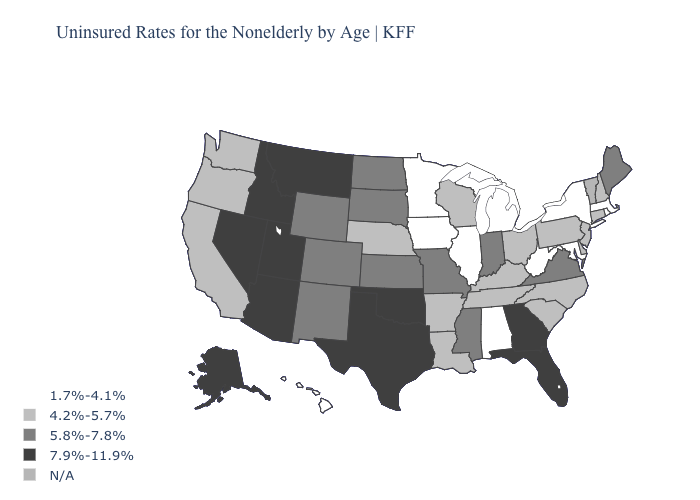What is the value of Arkansas?
Give a very brief answer. 4.2%-5.7%. Is the legend a continuous bar?
Short answer required. No. What is the highest value in states that border Iowa?
Be succinct. 5.8%-7.8%. Does the map have missing data?
Answer briefly. Yes. Name the states that have a value in the range 1.7%-4.1%?
Keep it brief. Alabama, Hawaii, Illinois, Iowa, Maryland, Massachusetts, Michigan, Minnesota, New York, Rhode Island, West Virginia. What is the value of North Dakota?
Short answer required. 5.8%-7.8%. What is the lowest value in the West?
Be succinct. 1.7%-4.1%. What is the highest value in states that border Utah?
Write a very short answer. 7.9%-11.9%. Among the states that border North Carolina , does Tennessee have the lowest value?
Quick response, please. Yes. Which states hav the highest value in the South?
Be succinct. Florida, Georgia, Oklahoma, Texas. What is the highest value in the USA?
Give a very brief answer. 7.9%-11.9%. Among the states that border North Dakota , which have the highest value?
Quick response, please. Montana. Does Kansas have the highest value in the MidWest?
Be succinct. Yes. Name the states that have a value in the range N/A?
Short answer required. Vermont. Name the states that have a value in the range 5.8%-7.8%?
Answer briefly. Colorado, Indiana, Kansas, Maine, Mississippi, Missouri, New Mexico, North Dakota, South Dakota, Virginia, Wyoming. 